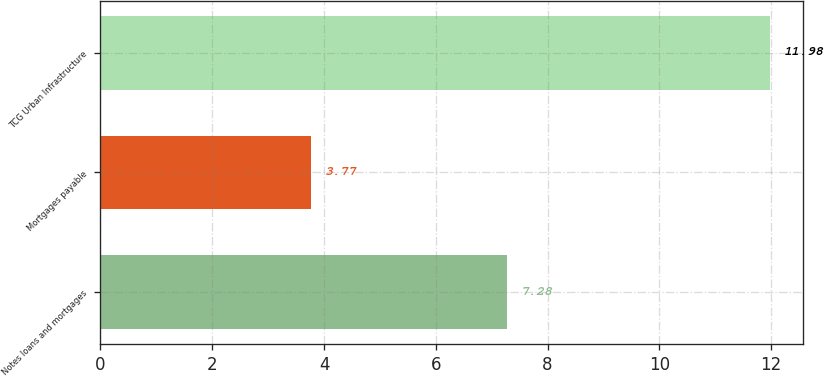Convert chart. <chart><loc_0><loc_0><loc_500><loc_500><bar_chart><fcel>Notes loans and mortgages<fcel>Mortgages payable<fcel>TCG Urban Infrastructure<nl><fcel>7.28<fcel>3.77<fcel>11.98<nl></chart> 